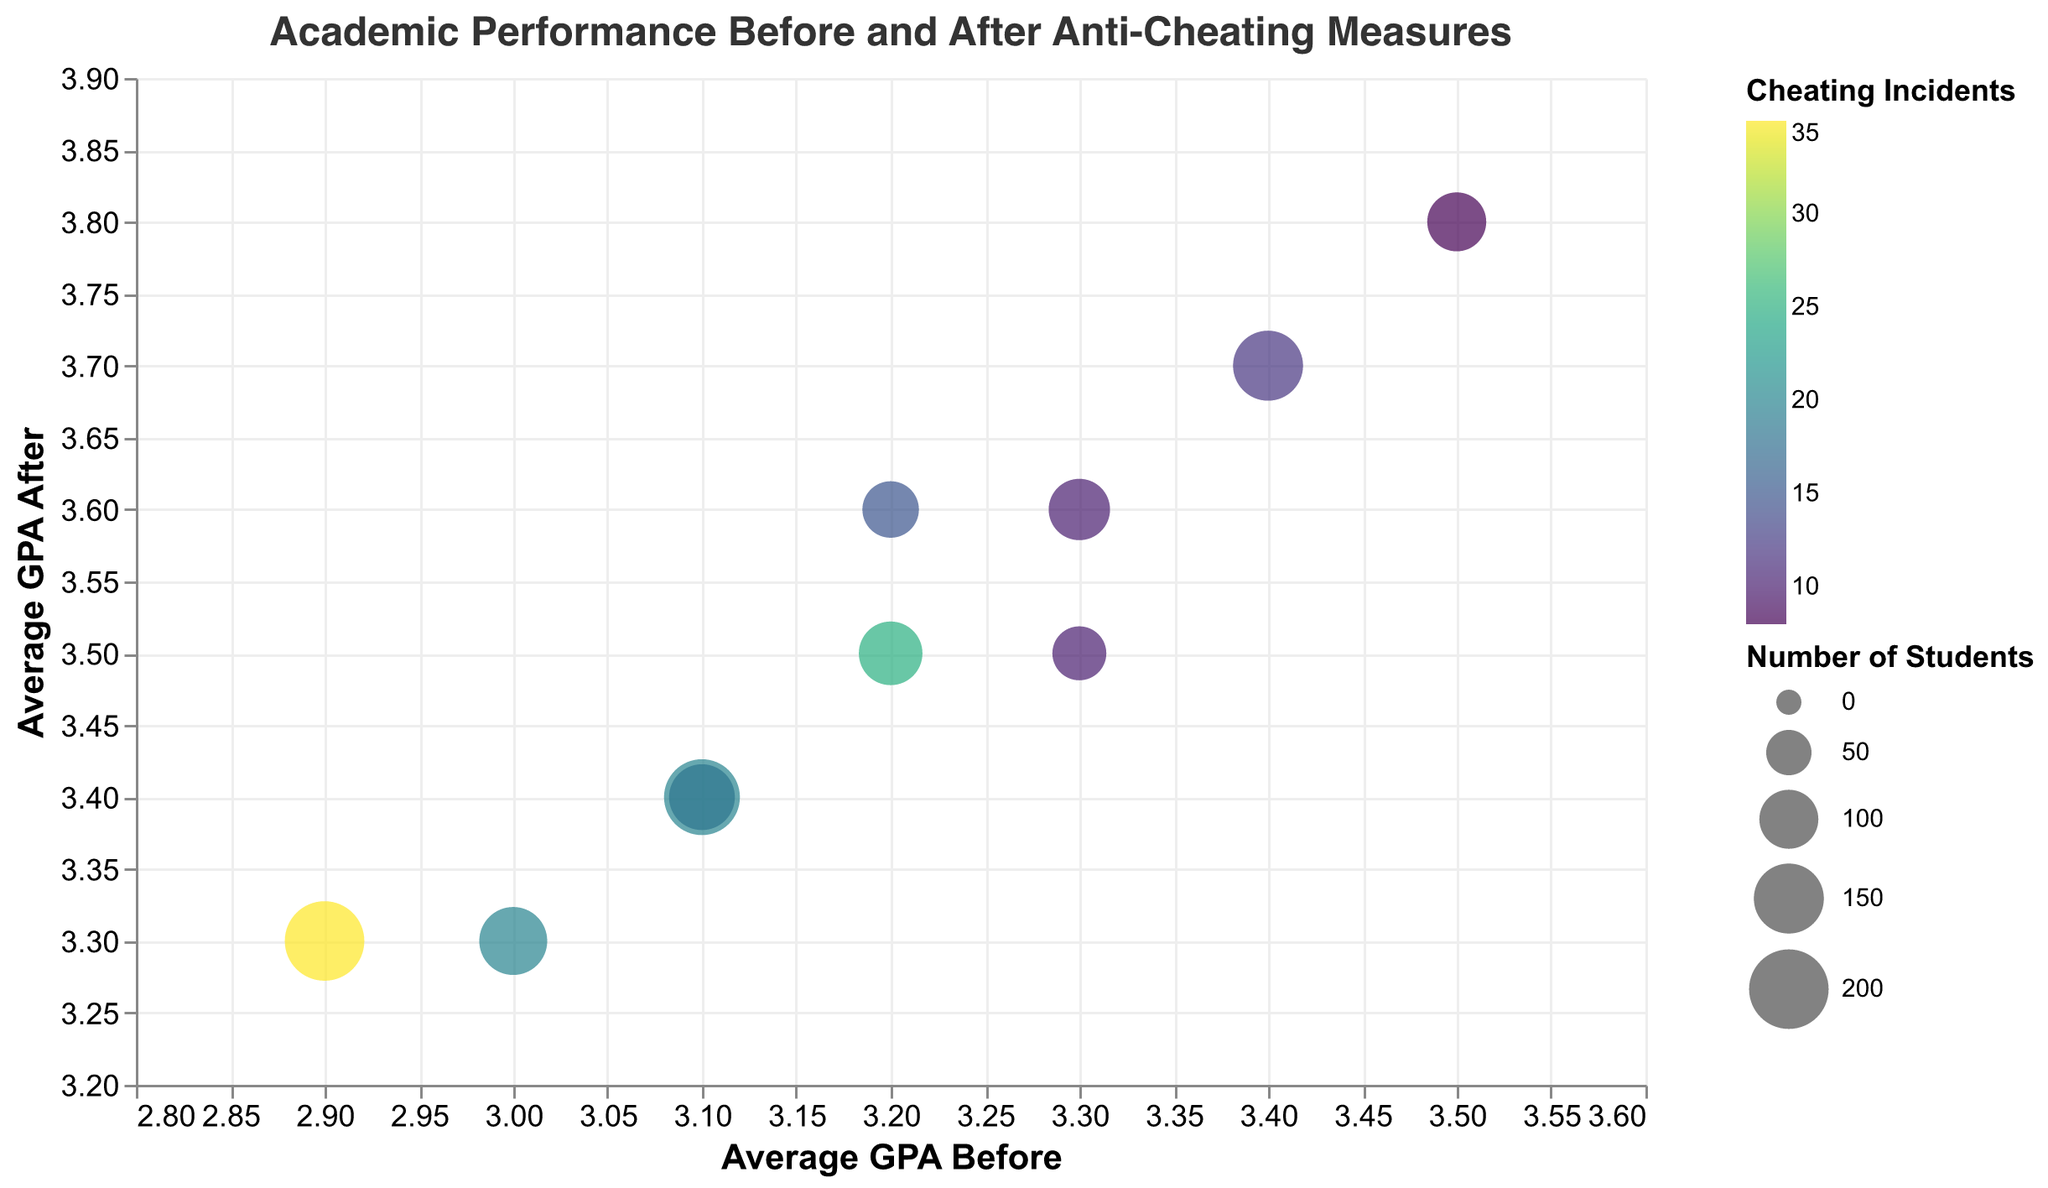What's the title of the figure? The title is often displayed at the top of the figure. In this case, the title is clearly shown as: "Academic Performance Before and After Anti-Cheating Measures."
Answer: Academic Performance Before and After Anti-Cheating Measures Which department had the highest average GPA before implementing anti-cheating measures? By looking at the x-axis and identifying the highest value, we see that the Chemistry department has a value of 3.5, the highest on the x-axis.
Answer: Chemistry What is the relationship between the average GPA before and after implementing anti-cheating measures in the Economics department? We identify the bubble representing the Economics department and compare its position on the x-axis and y-axis. The bubble for Economics is at (2.9, 3.3), showing an increase from 2.9 to 3.3.
Answer: Increase from 2.9 to 3.3 Which department has the largest bubble? The size of the bubble corresponds to the number of students, and the legend can help us identify this. The Economics department has a noticeably larger bubble compared to others, indicating it has the largest number of students.
Answer: Economics Which data point shows the highest number of cheating incidents? By referring to the color legend, we can identify the darkest bubble as the one with the most cheating incidents. The Economics department, with a cheating incident count of 35, shows the darkest hue.
Answer: Economics What is the average increase in GPA after implementing anti-cheating measures across all departments? We need to calculate the differences: 
Computer Science: 3.5-3.2=0.3; 
Mechanical Engineering: 3.3-3.0=0.3; 
Electrical Engineering: 3.4-3.1=0.3;
Civil Engineering: 3.6-3.3=0.3; 
Biology: 3.7-3.4=0.3; 
Chemistry: 3.8-3.5=0.3;
Physics: 3.6-3.2=0.4; 
Mathematics: 3.5-3.3=0.2; 
Economics: 3.3-2.9=0.4; 
Psychology: 3.4-3.1=0.3 
Summing these: (0.3+0.3+0.3+0.3+0.3+0.3+0.4+0.2+0.4+0.3)=3.1 
Average increase: 3.1/10 = 0.31
Answer: 0.31 Which department had the lowest improvement in average GPA after the measures? Look at the bubbles with the least y-axis shift from their x-axis position (vertical distance). Mathematics increased from 3.3 to 3.5, suggesting an improvement of only 0.2 GPA points, the lowest improvement among the departments.
Answer: Mathematics Is there any department that had the same number of cheating incidents before and after implementing the measures? In checking the data against the figure, no department visually represents having the same shading/color indicating identical cheating incident numbers before and after.
Answer: No Which department saw the greatest relative change in GPA after the anti-cheating measures? Calculate the relative change for each department:
Computer Science: (3.5-3.2)/3.2 ≈ 0.0938; 
Mechanical Engineering: (3.3-3.0)/3.0 ≈ 0.1; 
Electrical Engineering: (3.4-3.1)/3.1 ≈ 0.0968; 
Civil Engineering: (3.6-3.3)/3.3 ≈ 0.0909; 
Biology: (3.7-3.4)/3.4 ≈ 0.0882; 
Chemistry: (3.8-3.5)/3.5 ≈ 0.0857; 
Physics: (3.6-3.2)/3.2 ≈ 0.125; 
Mathematics: (3.5-3.3)/3.3 ≈ 0.0606; 
Economics: (3.3-2.9)/2.9 ≈ 0.1379; 
Psychology: (3.4-3.1)/3.1 ≈ 0.0968;
The highest relative change is for Economics: 0.1379
Answer: Economics What do the colors of the bubbles represent? The legend and the color gradient on the figure indicate that the bubble colors represent the number of cheating incidents, with the intensity of the color shading indicating the number of incidents.
Answer: Cheating incidents 